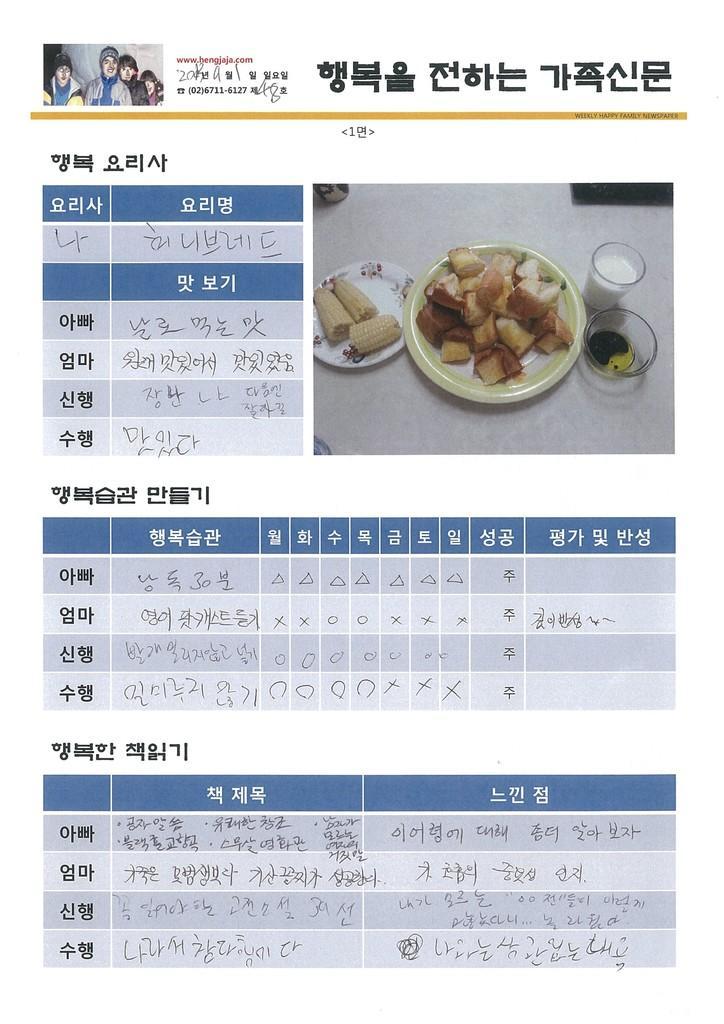Please provide a concise description of this image. In this image we can see the plates and glasses. Here we can see the corn in the plate and food items. Here we can see a glass of milk. At the left top corner we can see the pictures of some people. 